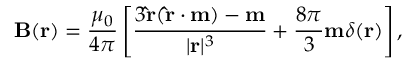<formula> <loc_0><loc_0><loc_500><loc_500>B ( r ) = { \frac { \mu _ { 0 } } { 4 \pi } } \left [ { \frac { 3 \hat { r } ( \hat { r } \cdot m ) - m } { | r | ^ { 3 } } } + { \frac { 8 \pi } { 3 } } m \delta ( r ) \right ] ,</formula> 